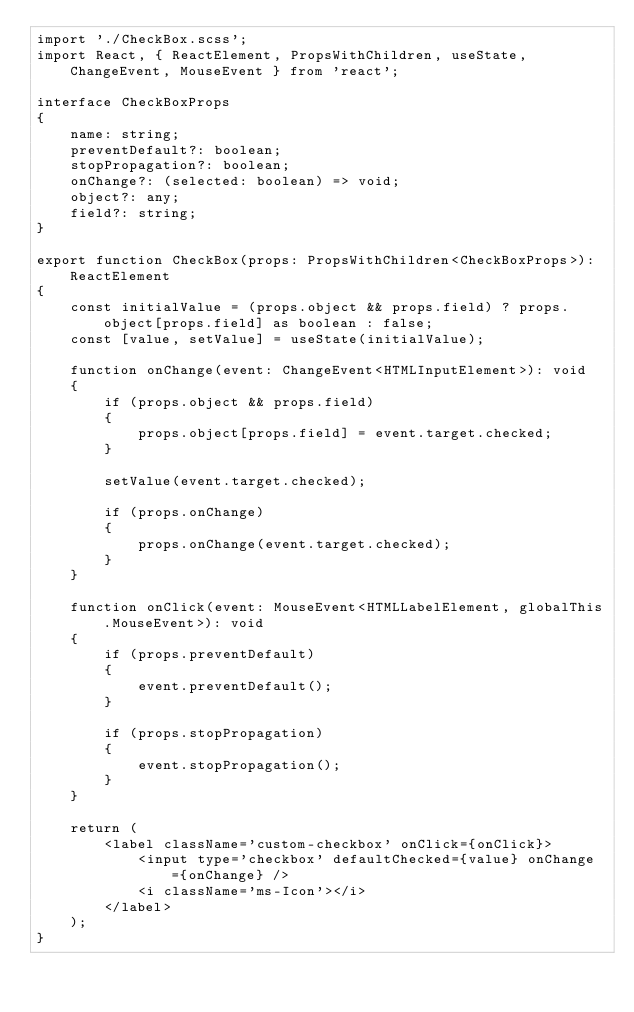<code> <loc_0><loc_0><loc_500><loc_500><_TypeScript_>import './CheckBox.scss';
import React, { ReactElement, PropsWithChildren, useState, ChangeEvent, MouseEvent } from 'react';

interface CheckBoxProps
{
    name: string;
    preventDefault?: boolean;
    stopPropagation?: boolean;
    onChange?: (selected: boolean) => void;
    object?: any;
    field?: string;
}

export function CheckBox(props: PropsWithChildren<CheckBoxProps>): ReactElement
{
    const initialValue = (props.object && props.field) ? props.object[props.field] as boolean : false;
    const [value, setValue] = useState(initialValue);

    function onChange(event: ChangeEvent<HTMLInputElement>): void
    {
        if (props.object && props.field)
        {
            props.object[props.field] = event.target.checked;
        }

        setValue(event.target.checked);

        if (props.onChange)
        {
            props.onChange(event.target.checked);
        }
    }

    function onClick(event: MouseEvent<HTMLLabelElement, globalThis.MouseEvent>): void
    {
        if (props.preventDefault)
        {
            event.preventDefault();
        }

        if (props.stopPropagation)
        {
            event.stopPropagation();
        }
    }

    return (
        <label className='custom-checkbox' onClick={onClick}>
            <input type='checkbox' defaultChecked={value} onChange={onChange} />
            <i className='ms-Icon'></i>
        </label>
    );
}
</code> 